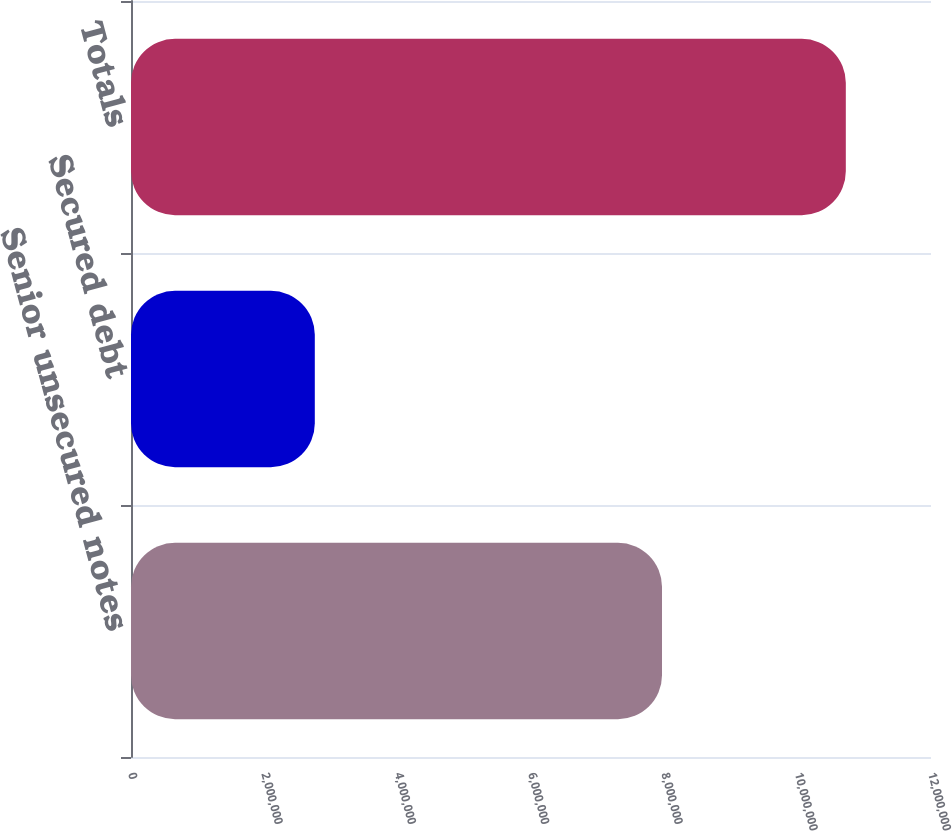Convert chart to OTSL. <chart><loc_0><loc_0><loc_500><loc_500><bar_chart><fcel>Senior unsecured notes<fcel>Secured debt<fcel>Totals<nl><fcel>7.96511e+06<fcel>2.75712e+06<fcel>1.07222e+07<nl></chart> 